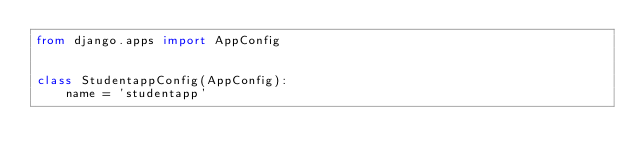<code> <loc_0><loc_0><loc_500><loc_500><_Python_>from django.apps import AppConfig


class StudentappConfig(AppConfig):
    name = 'studentapp'
</code> 